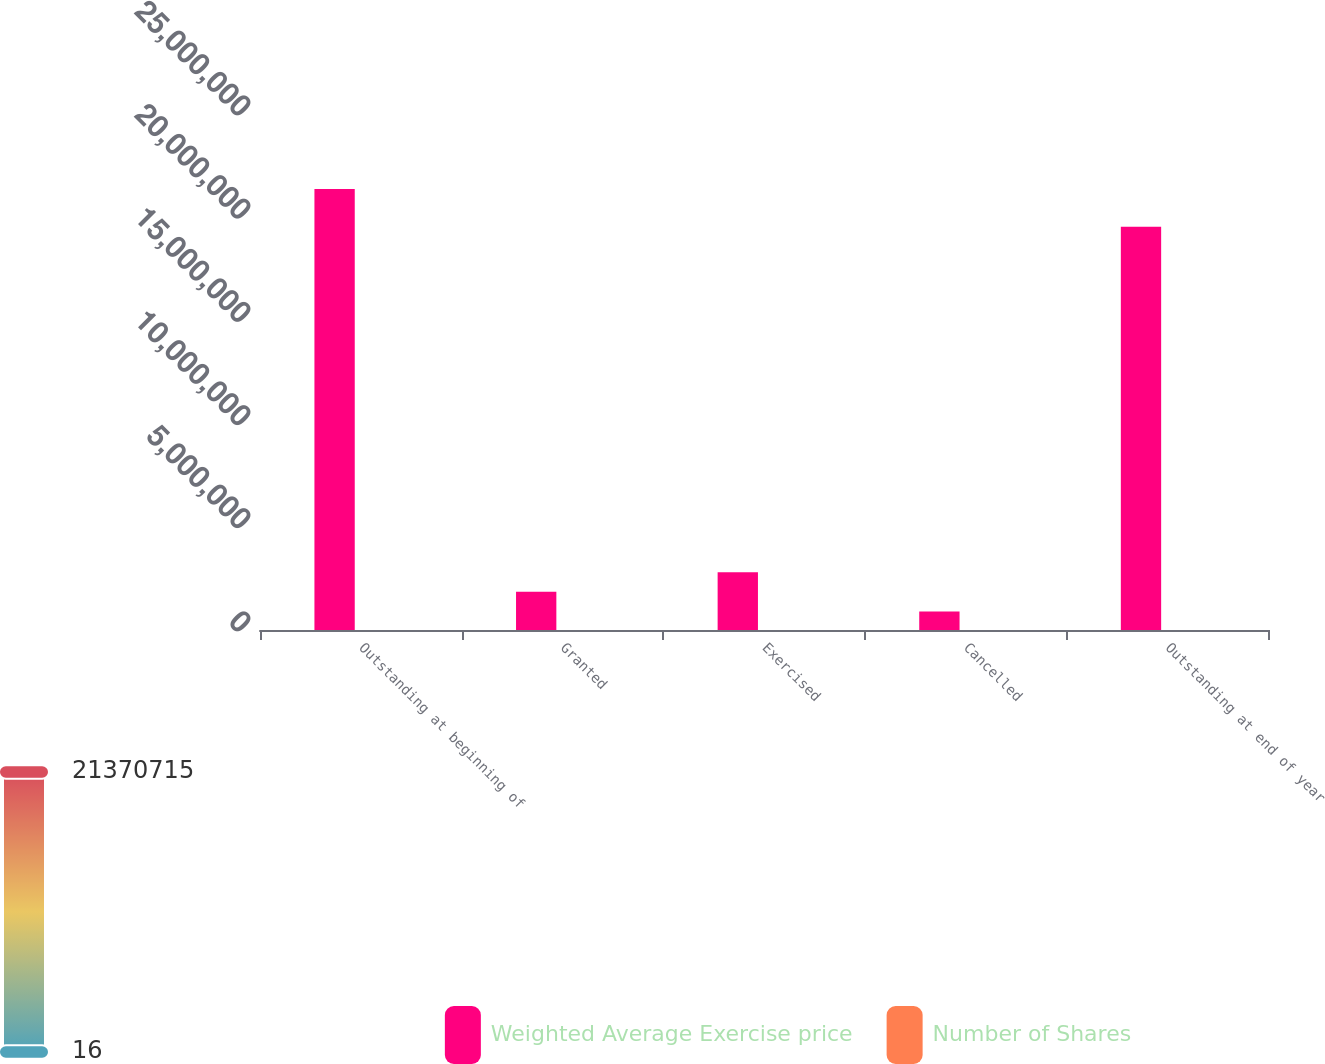<chart> <loc_0><loc_0><loc_500><loc_500><stacked_bar_chart><ecel><fcel>Outstanding at beginning of<fcel>Granted<fcel>Exercised<fcel>Cancelled<fcel>Outstanding at end of year<nl><fcel>Weighted Average Exercise price<fcel>2.13707e+07<fcel>1.85887e+06<fcel>2.79561e+06<fcel>897010<fcel>1.9537e+07<nl><fcel>Number of Shares<fcel>24.41<fcel>33.52<fcel>16.46<fcel>29.29<fcel>26.19<nl></chart> 